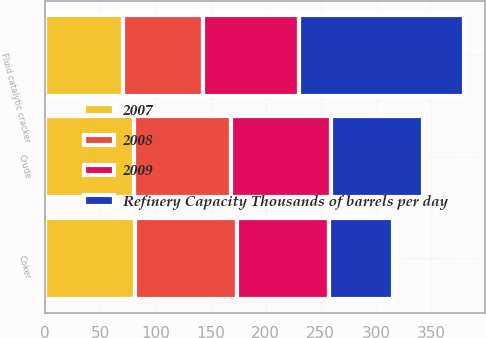Convert chart. <chart><loc_0><loc_0><loc_500><loc_500><stacked_bar_chart><ecel><fcel>Crude<fcel>Fluid catalytic cracker<fcel>Coker<nl><fcel>Refinery Capacity Thousands of barrels per day<fcel>83.4<fcel>150<fcel>58<nl><fcel>2007<fcel>80.3<fcel>70.2<fcel>81.6<nl><fcel>2008<fcel>88.2<fcel>72.7<fcel>92.4<nl><fcel>2009<fcel>90.8<fcel>87.1<fcel>83.4<nl></chart> 